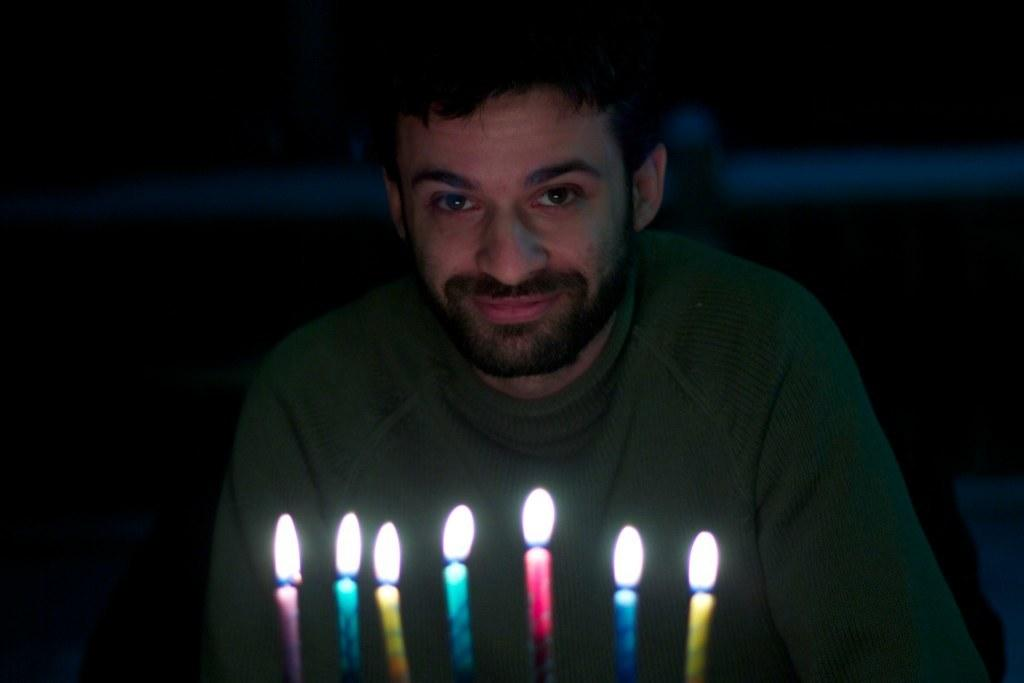What objects can be seen in the image? There are candles in the image. Can you describe the person in the image? A person is present in the image, and they have a smile on their face. What is in the background of the image? There is a metal rod in the background of the image. How many ants are crawling on the candles in the image? There are no ants present in the image; it only features candles and a person with a smile. What time of day is it in the image, based on the hour? The provided facts do not mention the time of day or any indication of the hour, so it cannot be determined from the image. 